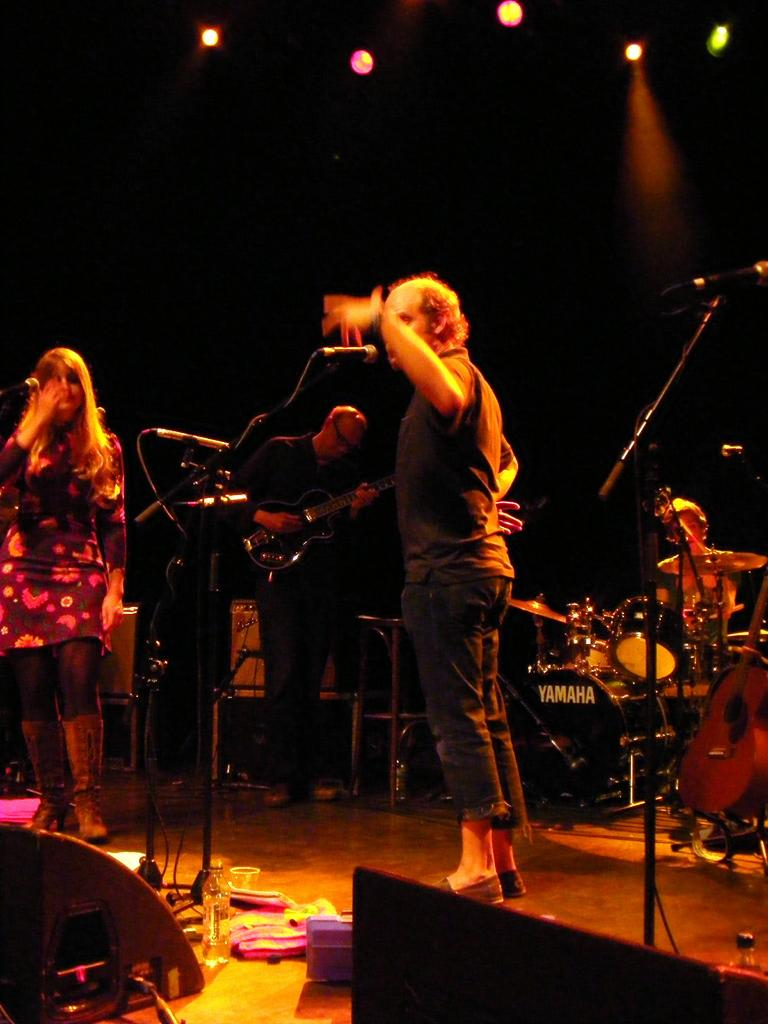What is the main subject in the middle of the image? There is a man standing in the middle of the image. Who is standing on the left side of the image? There is a woman standing on the left side of the image. What can be seen in the background of the image? There are music instruments and a black color wall in the background of the image. Where is the throne located in the image? There is no throne present in the image. What type of neck accessory is the man wearing in the image? The man is not wearing any neck accessory in the image. 